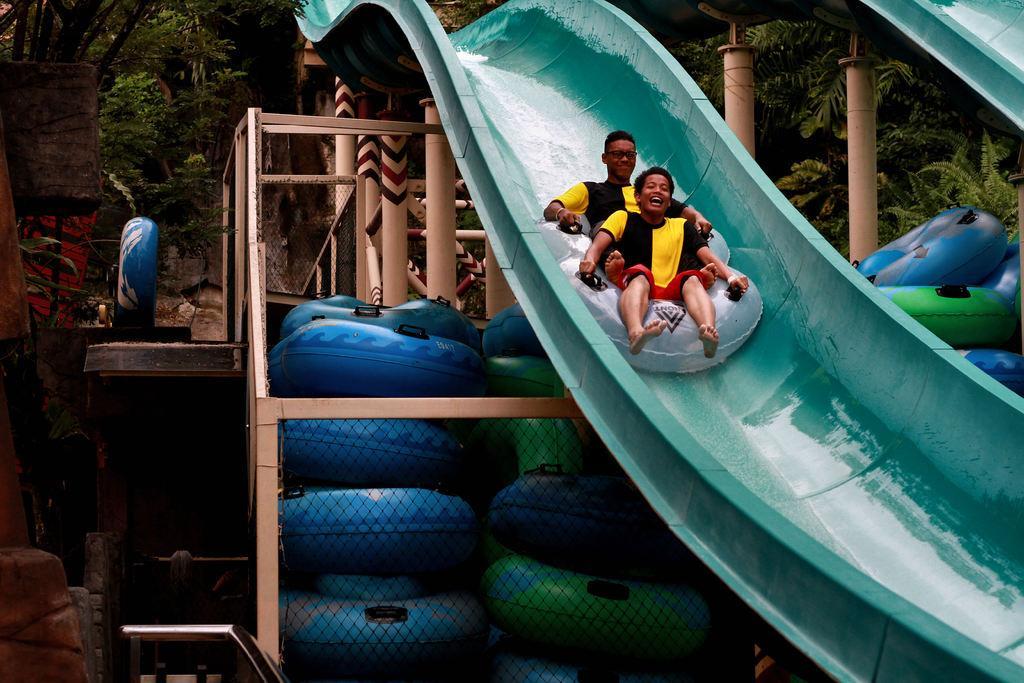In one or two sentences, can you explain what this image depicts? In this picture there are two people sitting on tubes and we can see sliders, poles, tubes, mesh and rod. In the background of the image we can see trees. 